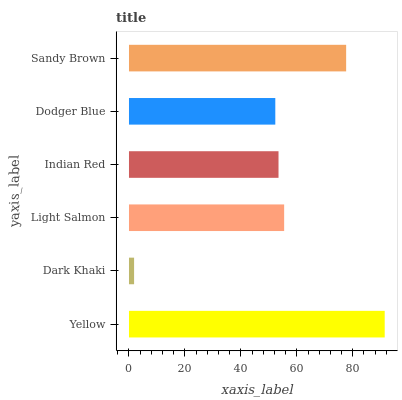Is Dark Khaki the minimum?
Answer yes or no. Yes. Is Yellow the maximum?
Answer yes or no. Yes. Is Light Salmon the minimum?
Answer yes or no. No. Is Light Salmon the maximum?
Answer yes or no. No. Is Light Salmon greater than Dark Khaki?
Answer yes or no. Yes. Is Dark Khaki less than Light Salmon?
Answer yes or no. Yes. Is Dark Khaki greater than Light Salmon?
Answer yes or no. No. Is Light Salmon less than Dark Khaki?
Answer yes or no. No. Is Light Salmon the high median?
Answer yes or no. Yes. Is Indian Red the low median?
Answer yes or no. Yes. Is Dodger Blue the high median?
Answer yes or no. No. Is Dark Khaki the low median?
Answer yes or no. No. 